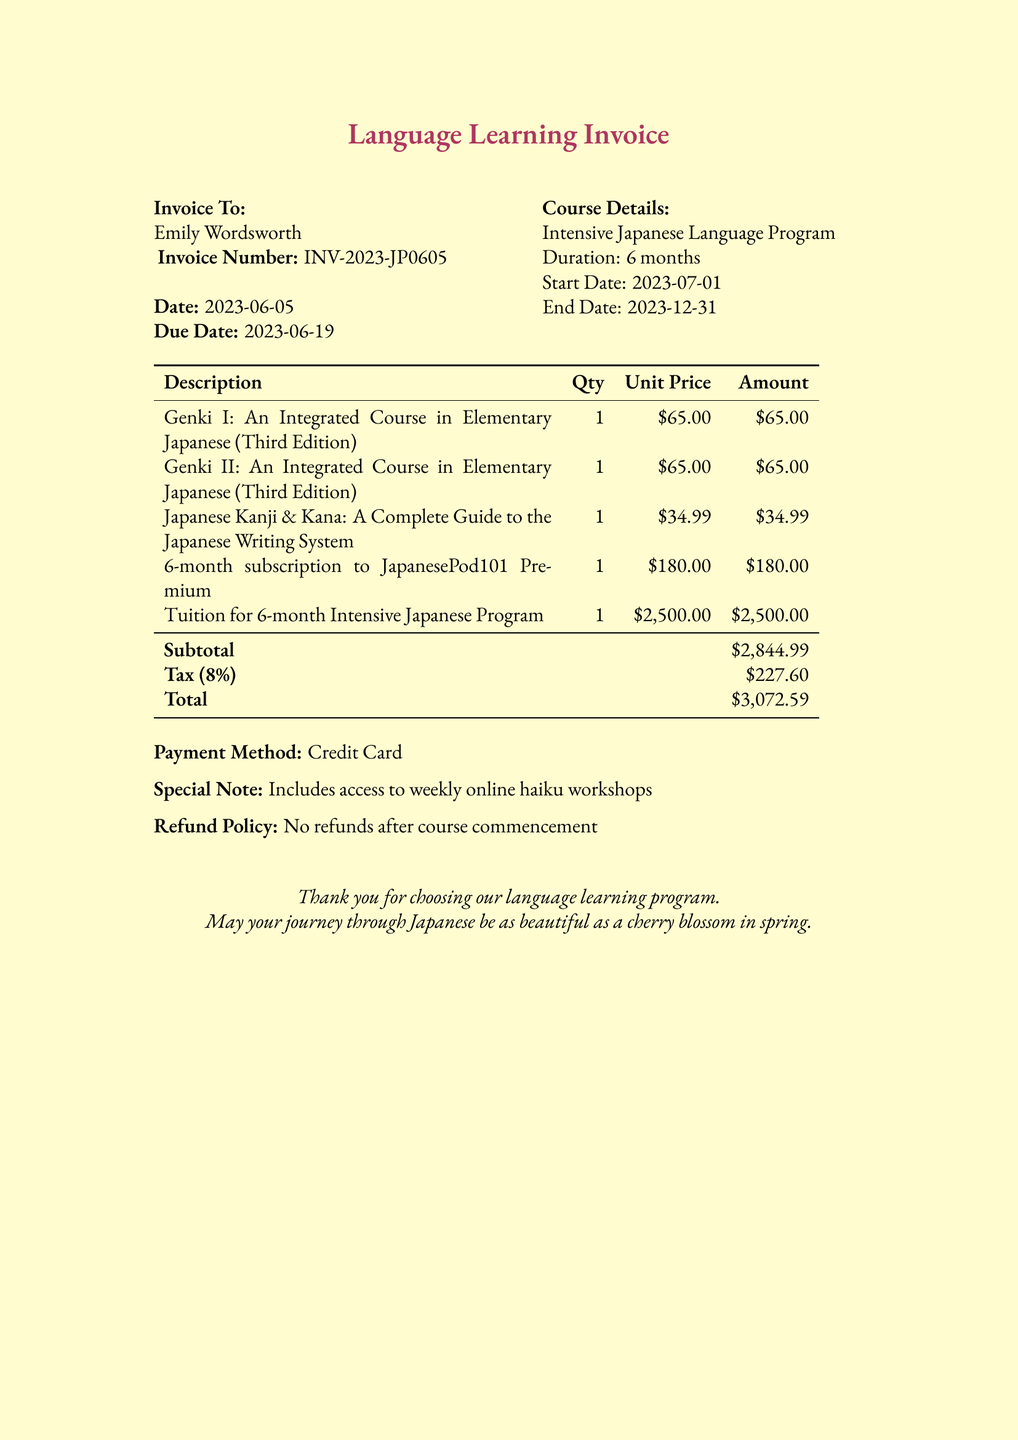What is the invoice number? The invoice number is a unique identifier listed in the document, which is INV-2023-JP0605.
Answer: INV-2023-JP0605 What is the total amount due? The total amount due is provided at the end of the invoice, which sums up all charges, including tax.
Answer: $3,072.59 Who is the invoice addressed to? The document provides the name of the recipient to whom the invoice is addressed.
Answer: Emily Wordsworth What is the duration of the language program? The duration is specified in the course details section of the invoice.
Answer: 6 months What is the tax rate applied? The tax rate is mentioned as a percentage in the subtotal section of the invoice.
Answer: 8% What is included in the special note? The special note provides additional information regarding included features in the program.
Answer: Includes access to weekly online haiku workshops What are the included textbooks? The document lists the textbooks as part of the course fees, which can be found under the description.
Answer: Genki I, Genki II, Japanese Kanji & Kana When does the course start? The start date is explicitly mentioned in the course details section of the invoice.
Answer: 2023-07-01 What is the refund policy stated in this invoice? The refund policy is included to inform the recipient about the terms related to refunds.
Answer: No refunds after course commencement 